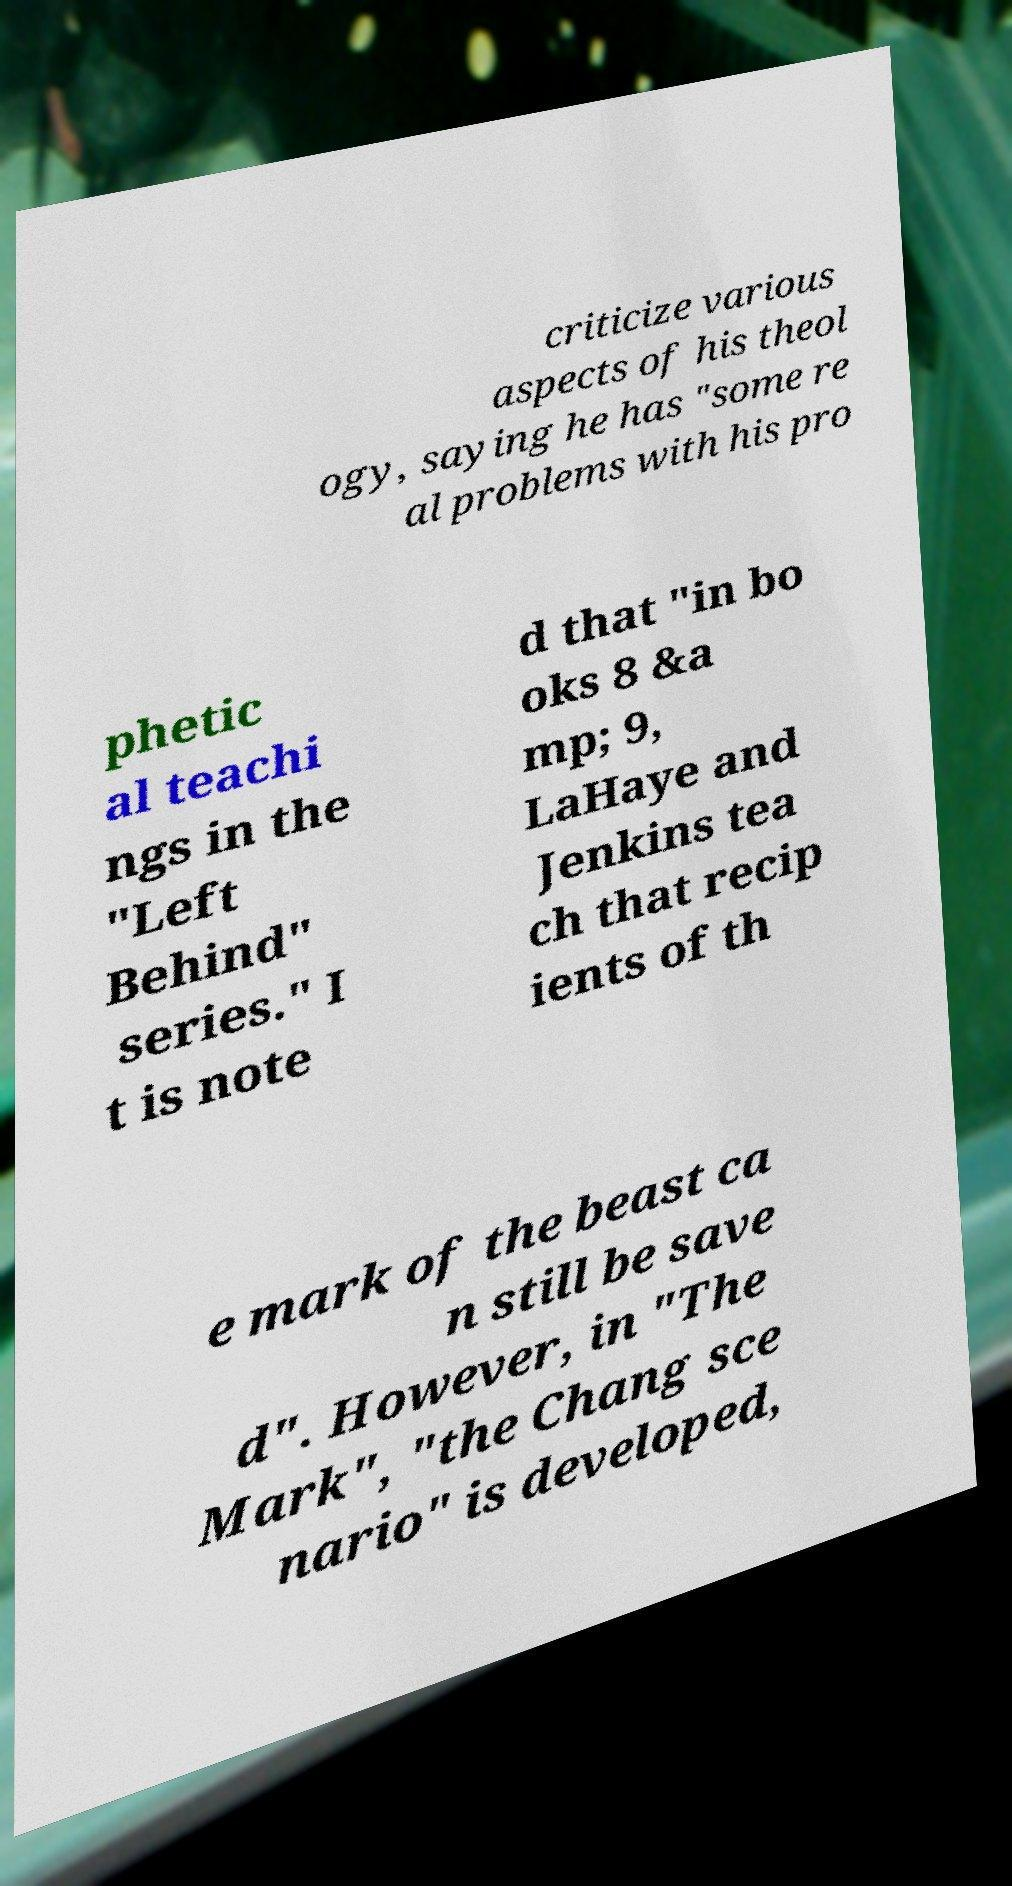Could you extract and type out the text from this image? criticize various aspects of his theol ogy, saying he has "some re al problems with his pro phetic al teachi ngs in the "Left Behind" series." I t is note d that "in bo oks 8 &a mp; 9, LaHaye and Jenkins tea ch that recip ients of th e mark of the beast ca n still be save d". However, in "The Mark", "the Chang sce nario" is developed, 